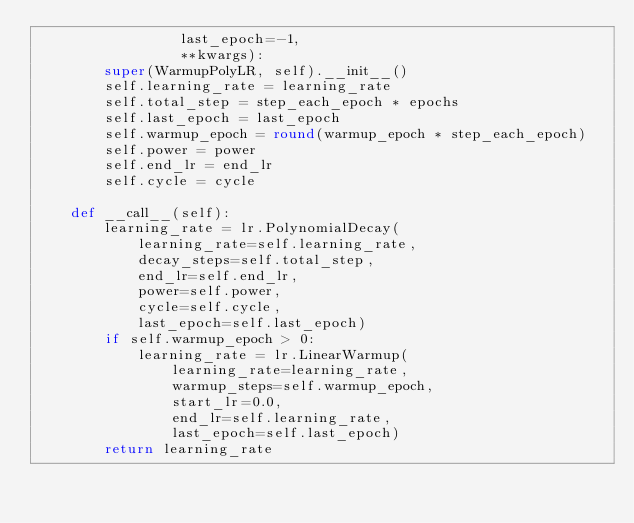<code> <loc_0><loc_0><loc_500><loc_500><_Python_>                 last_epoch=-1,
                 **kwargs):
        super(WarmupPolyLR, self).__init__()
        self.learning_rate = learning_rate
        self.total_step = step_each_epoch * epochs
        self.last_epoch = last_epoch
        self.warmup_epoch = round(warmup_epoch * step_each_epoch)
        self.power = power
        self.end_lr = end_lr
        self.cycle = cycle

    def __call__(self):
        learning_rate = lr.PolynomialDecay(
            learning_rate=self.learning_rate,
            decay_steps=self.total_step,
            end_lr=self.end_lr,
            power=self.power,
            cycle=self.cycle,
            last_epoch=self.last_epoch)
        if self.warmup_epoch > 0:
            learning_rate = lr.LinearWarmup(
                learning_rate=learning_rate,
                warmup_steps=self.warmup_epoch,
                start_lr=0.0,
                end_lr=self.learning_rate,
                last_epoch=self.last_epoch)
        return learning_rate
</code> 